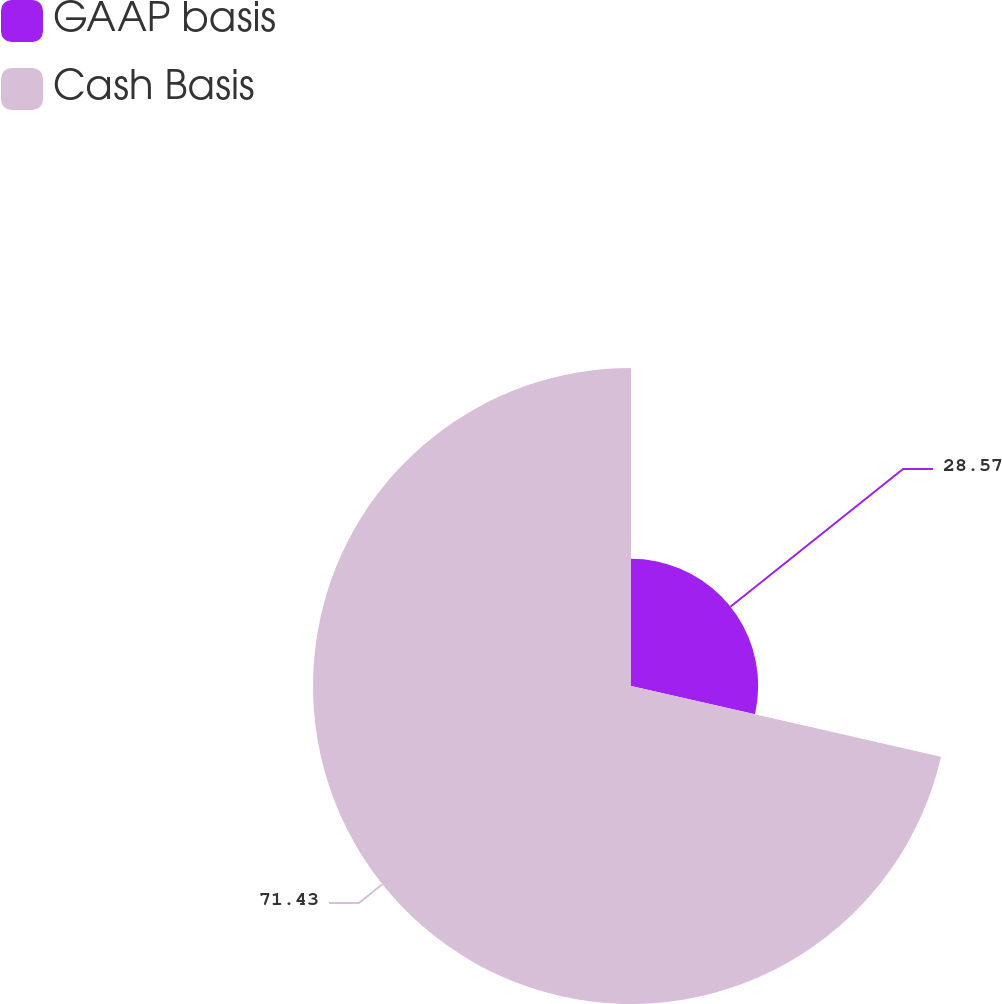<chart> <loc_0><loc_0><loc_500><loc_500><pie_chart><fcel>GAAP basis<fcel>Cash Basis<nl><fcel>28.57%<fcel>71.43%<nl></chart> 